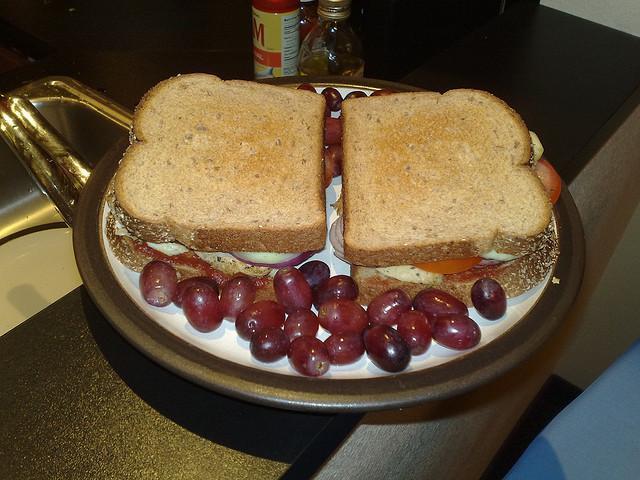How many sandwiches are there?
Give a very brief answer. 2. 